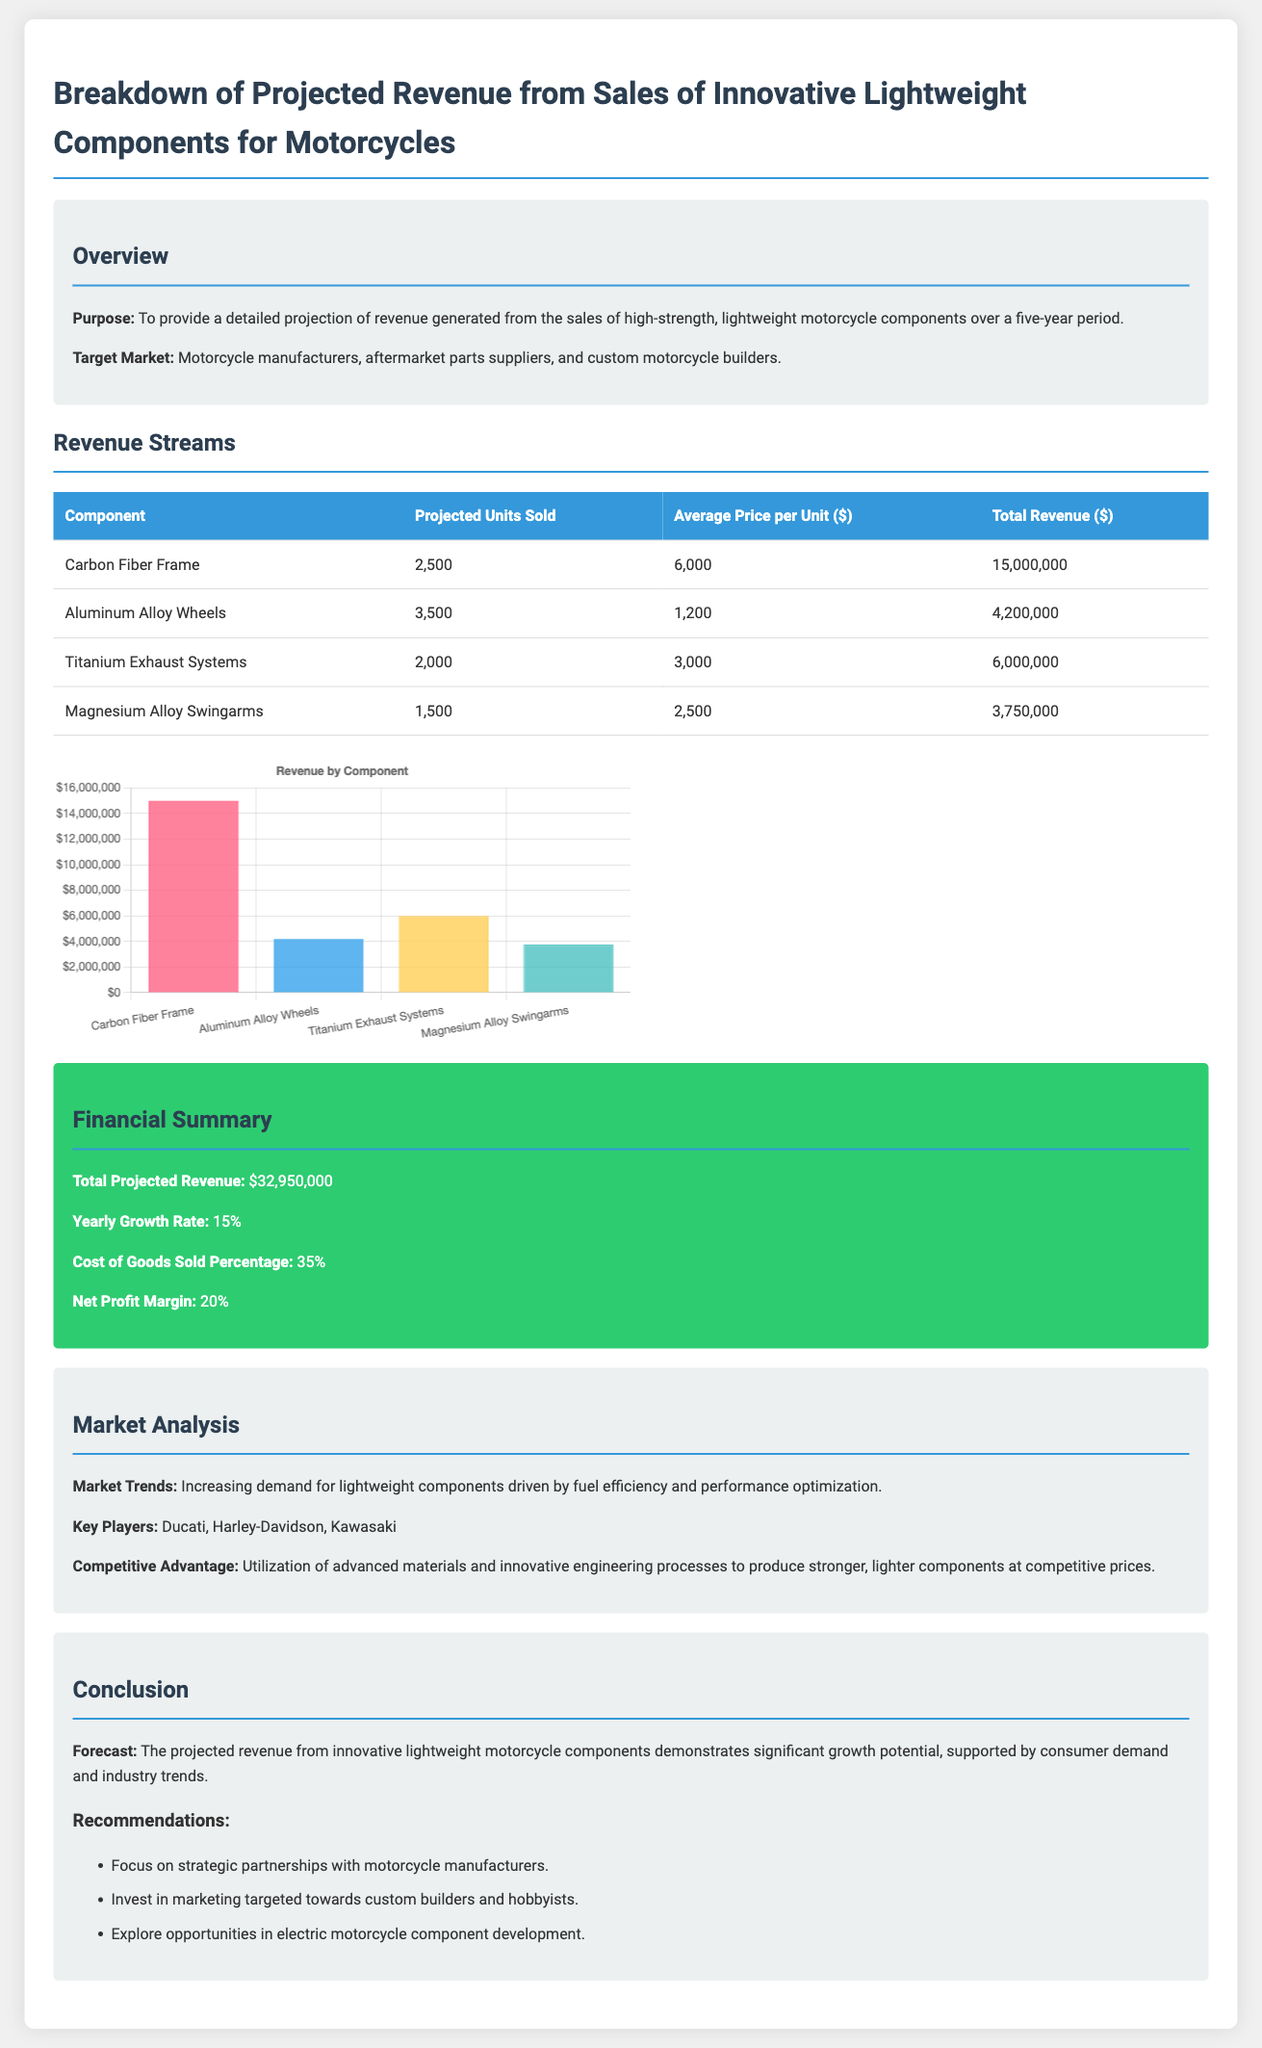What is the purpose of the document? The purpose is to provide a detailed projection of revenue generated from sales of high-strength, lightweight motorcycle components over a five-year period.
Answer: To provide a detailed projection of revenue generated from sales of high-strength, lightweight motorcycle components over a five-year period What is the projected revenue from Carbon Fiber Frames? The document lists the projected revenue from Carbon Fiber Frames as $15,000,000.
Answer: $15,000,000 What is the average price per unit for Aluminum Alloy Wheels? The average price per unit for Aluminum Alloy Wheels is specified as $1,200.
Answer: $1,200 What is the total projected revenue from all components? The total projected revenue is the sum of individual components, which adds up to $32,950,000.
Answer: $32,950,000 What is the net profit margin indicated in the financial summary? The net profit margin is stated as 20%.
Answer: 20% Which component has the highest projected units sold? The component with the highest projected units sold is Aluminum Alloy Wheels, with 3,500 units.
Answer: Aluminum Alloy Wheels What is the yearly growth rate anticipated in the document? The yearly growth rate is projected to be 15%.
Answer: 15% What market trend is highlighted in the market analysis? The highlighted market trend is increasing demand for lightweight components driven by fuel efficiency and performance optimization.
Answer: Increasing demand for lightweight components driven by fuel efficiency and performance optimization What is the key competitive advantage mentioned in the document? The competitive advantage mentioned is the utilization of advanced materials and innovative engineering processes to produce stronger, lighter components at competitive prices.
Answer: Utilization of advanced materials and innovative engineering processes to produce stronger, lighter components at competitive prices 